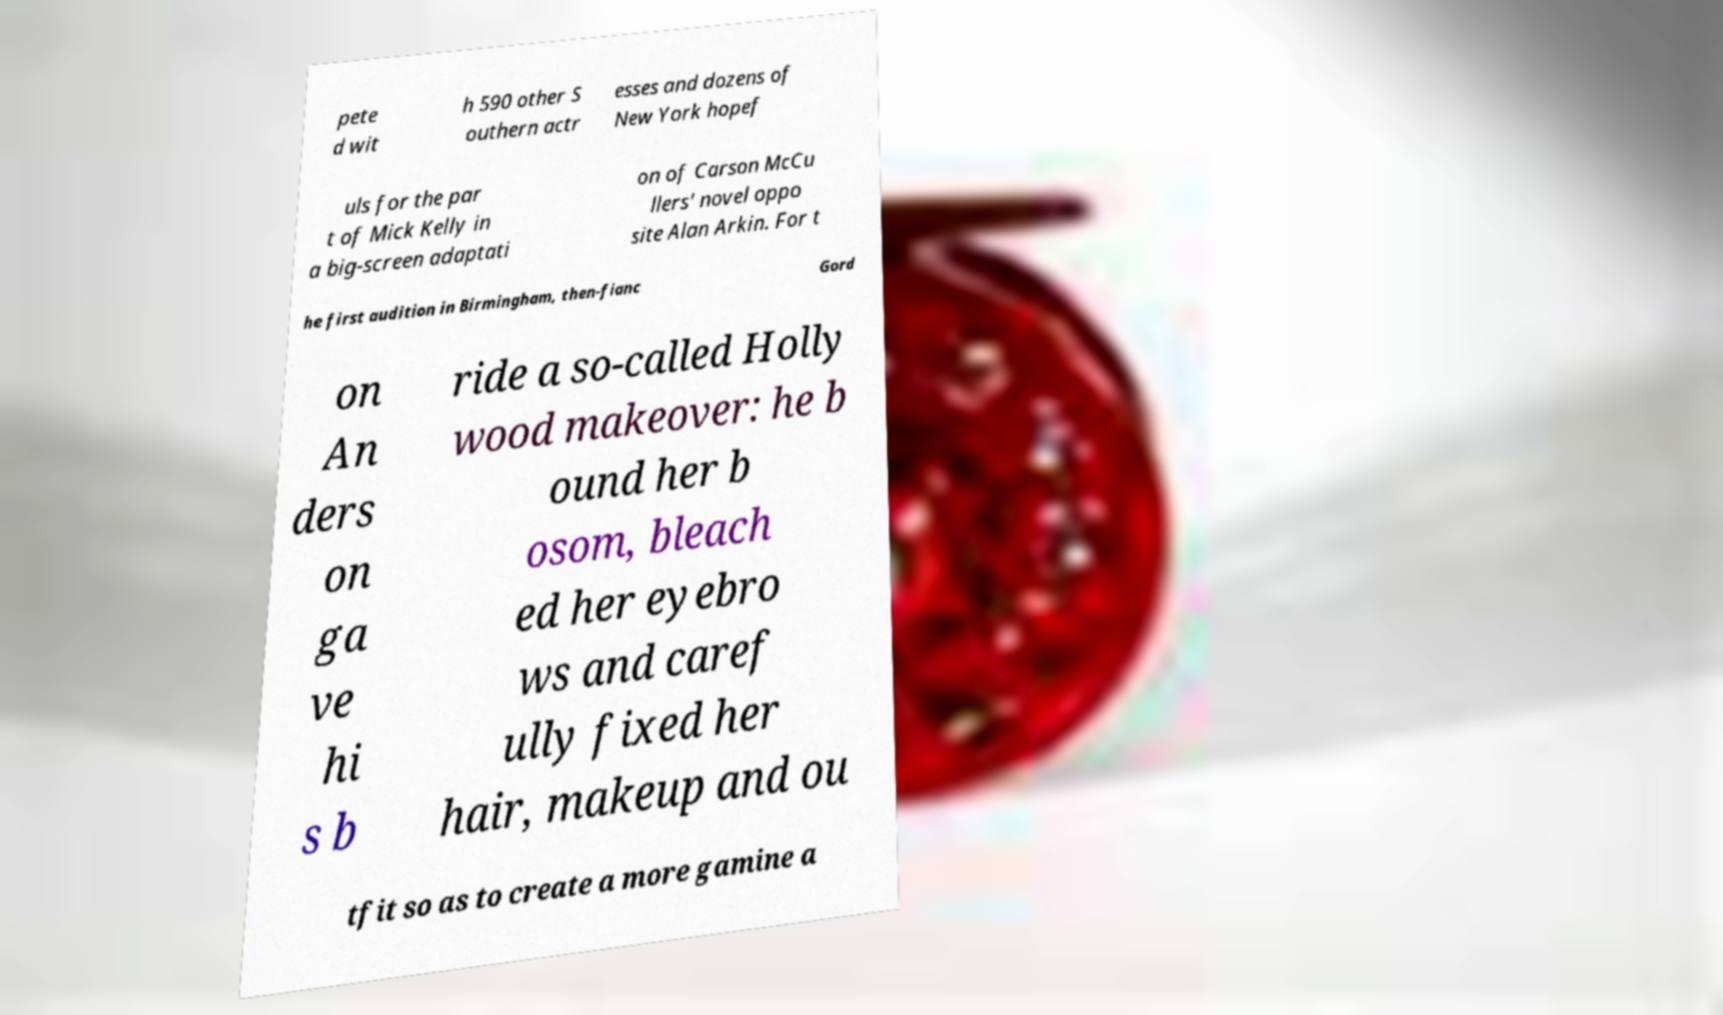Could you assist in decoding the text presented in this image and type it out clearly? pete d wit h 590 other S outhern actr esses and dozens of New York hopef uls for the par t of Mick Kelly in a big-screen adaptati on of Carson McCu llers' novel oppo site Alan Arkin. For t he first audition in Birmingham, then-fianc Gord on An ders on ga ve hi s b ride a so-called Holly wood makeover: he b ound her b osom, bleach ed her eyebro ws and caref ully fixed her hair, makeup and ou tfit so as to create a more gamine a 